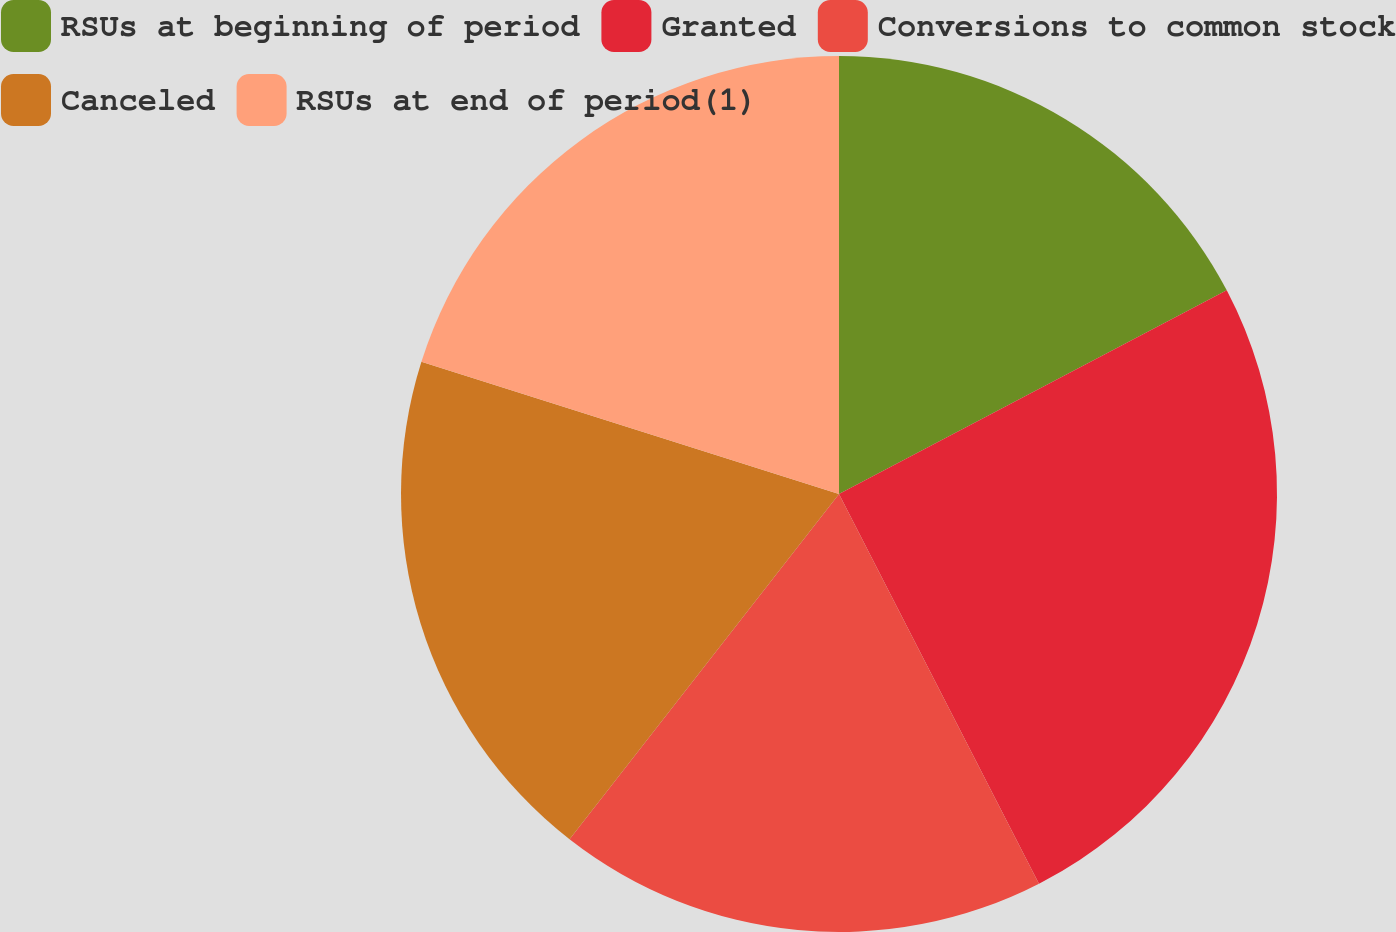<chart> <loc_0><loc_0><loc_500><loc_500><pie_chart><fcel>RSUs at beginning of period<fcel>Granted<fcel>Conversions to common stock<fcel>Canceled<fcel>RSUs at end of period(1)<nl><fcel>17.3%<fcel>25.15%<fcel>18.09%<fcel>19.33%<fcel>20.12%<nl></chart> 